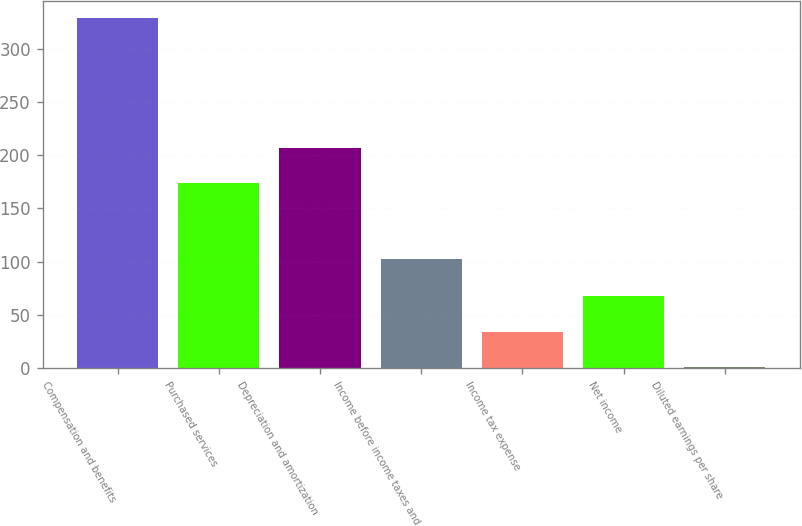Convert chart to OTSL. <chart><loc_0><loc_0><loc_500><loc_500><bar_chart><fcel>Compensation and benefits<fcel>Purchased services<fcel>Depreciation and amortization<fcel>Income before income taxes and<fcel>Income tax expense<fcel>Net income<fcel>Diluted earnings per share<nl><fcel>328.7<fcel>173.7<fcel>206.51<fcel>102.2<fcel>34.1<fcel>68.1<fcel>0.6<nl></chart> 